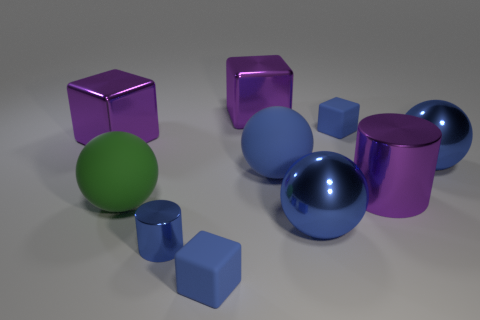Is the purple block that is right of the tiny cylinder made of the same material as the green sphere?
Provide a succinct answer. No. What is the material of the purple block that is right of the cylinder in front of the blue sphere in front of the purple cylinder?
Offer a very short reply. Metal. What number of objects are big purple metal cylinders or things that are in front of the large purple cylinder?
Ensure brevity in your answer.  5. What color is the large cylinder that is on the right side of the blue cylinder?
Keep it short and to the point. Purple. What is the shape of the small blue metal thing?
Your answer should be very brief. Cylinder. What is the material of the green object that is in front of the metallic cylinder that is right of the large blue matte sphere?
Provide a succinct answer. Rubber. What number of other things are the same material as the small blue cylinder?
Ensure brevity in your answer.  5. What material is the purple cylinder that is the same size as the green thing?
Make the answer very short. Metal. Are there more blue matte blocks that are in front of the green rubber sphere than small blue metallic cylinders behind the blue metallic cylinder?
Keep it short and to the point. Yes. Is there another metal object that has the same shape as the green object?
Your response must be concise. Yes. 